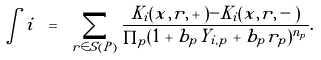<formula> <loc_0><loc_0><loc_500><loc_500>\int i \ = \ \sum _ { r \in S ( P ) } \frac { K _ { i } ( x , r , + ) - K _ { i } ( x , r , - ) } { \prod _ { p } ( 1 + b _ { p } Y _ { i , p } + b _ { p } r _ { p } ) ^ { n _ { p } } } .</formula> 